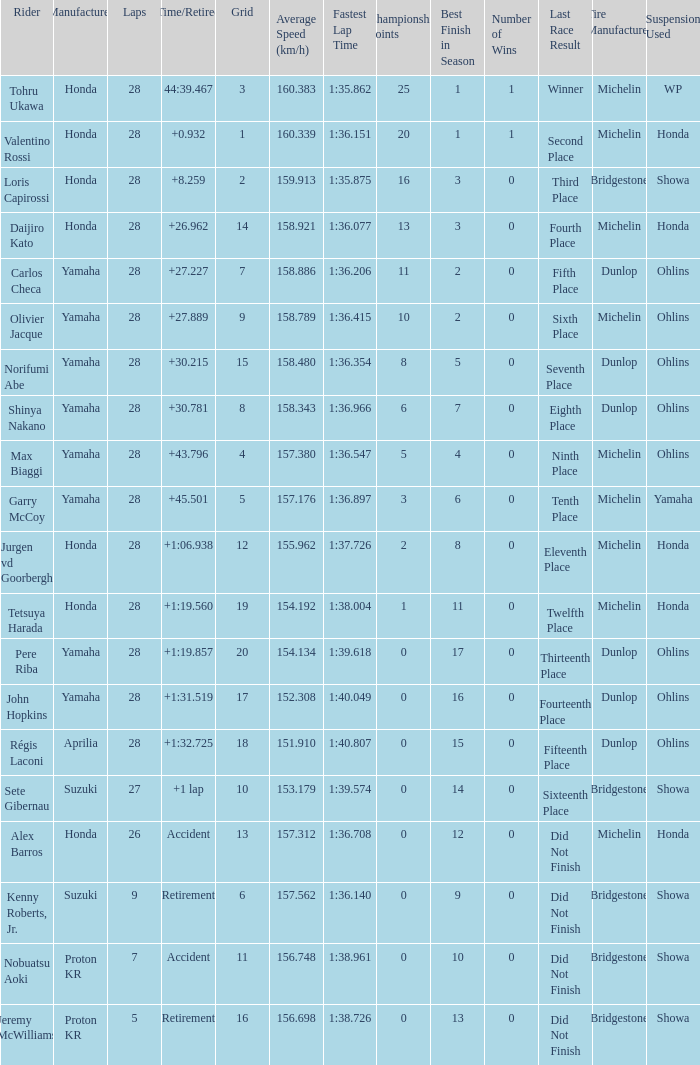Can you parse all the data within this table? {'header': ['Rider', 'Manufacturer', 'Laps', 'Time/Retired', 'Grid', 'Average Speed (km/h)', 'Fastest Lap Time', 'Championship Points', 'Best Finish in Season', 'Number of Wins', 'Last Race Result', 'Tire Manufacturer', 'Suspension Used '], 'rows': [['Tohru Ukawa', 'Honda', '28', '44:39.467', '3', '160.383', '1:35.862', '25', '1', '1', 'Winner', 'Michelin', 'WP'], ['Valentino Rossi', 'Honda', '28', '+0.932', '1', '160.339', '1:36.151', '20', '1', '1', 'Second Place', 'Michelin', 'Honda'], ['Loris Capirossi', 'Honda', '28', '+8.259', '2', '159.913', '1:35.875', '16', '3', '0', 'Third Place', 'Bridgestone', 'Showa'], ['Daijiro Kato', 'Honda', '28', '+26.962', '14', '158.921', '1:36.077', '13', '3', '0', 'Fourth Place', 'Michelin', 'Honda'], ['Carlos Checa', 'Yamaha', '28', '+27.227', '7', '158.886', '1:36.206', '11', '2', '0', 'Fifth Place', 'Dunlop', 'Ohlins'], ['Olivier Jacque', 'Yamaha', '28', '+27.889', '9', '158.789', '1:36.415', '10', '2', '0', 'Sixth Place', 'Michelin', 'Ohlins'], ['Norifumi Abe', 'Yamaha', '28', '+30.215', '15', '158.480', '1:36.354', '8', '5', '0', 'Seventh Place', 'Dunlop', 'Ohlins'], ['Shinya Nakano', 'Yamaha', '28', '+30.781', '8', '158.343', '1:36.966', '6', '7', '0', 'Eighth Place', 'Dunlop', 'Ohlins'], ['Max Biaggi', 'Yamaha', '28', '+43.796', '4', '157.380', '1:36.547', '5', '4', '0', 'Ninth Place', 'Michelin', 'Ohlins'], ['Garry McCoy', 'Yamaha', '28', '+45.501', '5', '157.176', '1:36.897', '3', '6', '0', 'Tenth Place', 'Michelin', 'Yamaha'], ['Jurgen vd Goorbergh', 'Honda', '28', '+1:06.938', '12', '155.962', '1:37.726', '2', '8', '0', 'Eleventh Place', 'Michelin', 'Honda'], ['Tetsuya Harada', 'Honda', '28', '+1:19.560', '19', '154.192', '1:38.004', '1', '11', '0', 'Twelfth Place', 'Michelin', 'Honda'], ['Pere Riba', 'Yamaha', '28', '+1:19.857', '20', '154.134', '1:39.618', '0', '17', '0', 'Thirteenth Place', 'Dunlop', 'Ohlins'], ['John Hopkins', 'Yamaha', '28', '+1:31.519', '17', '152.308', '1:40.049', '0', '16', '0', 'Fourteenth Place', 'Dunlop', 'Ohlins'], ['Régis Laconi', 'Aprilia', '28', '+1:32.725', '18', '151.910', '1:40.807', '0', '15', '0', 'Fifteenth Place', 'Dunlop', 'Ohlins'], ['Sete Gibernau', 'Suzuki', '27', '+1 lap', '10', '153.179', '1:39.574', '0', '14', '0', 'Sixteenth Place', 'Bridgestone', 'Showa'], ['Alex Barros', 'Honda', '26', 'Accident', '13', '157.312', '1:36.708', '0', '12', '0', 'Did Not Finish', 'Michelin', 'Honda'], ['Kenny Roberts, Jr.', 'Suzuki', '9', 'Retirement', '6', '157.562', '1:36.140', '0', '9', '0', 'Did Not Finish', 'Bridgestone', 'Showa'], ['Nobuatsu Aoki', 'Proton KR', '7', 'Accident', '11', '156.748', '1:38.961', '0', '10', '0', 'Did Not Finish', 'Bridgestone', 'Showa'], ['Jeremy McWilliams', 'Proton KR', '5', 'Retirement', '16', '156.698', '1:38.726', '0', '13', '0', 'Did Not Finish', 'Bridgestone', 'Showa']]} What is the count of laps that pere riba rode? 28.0. 